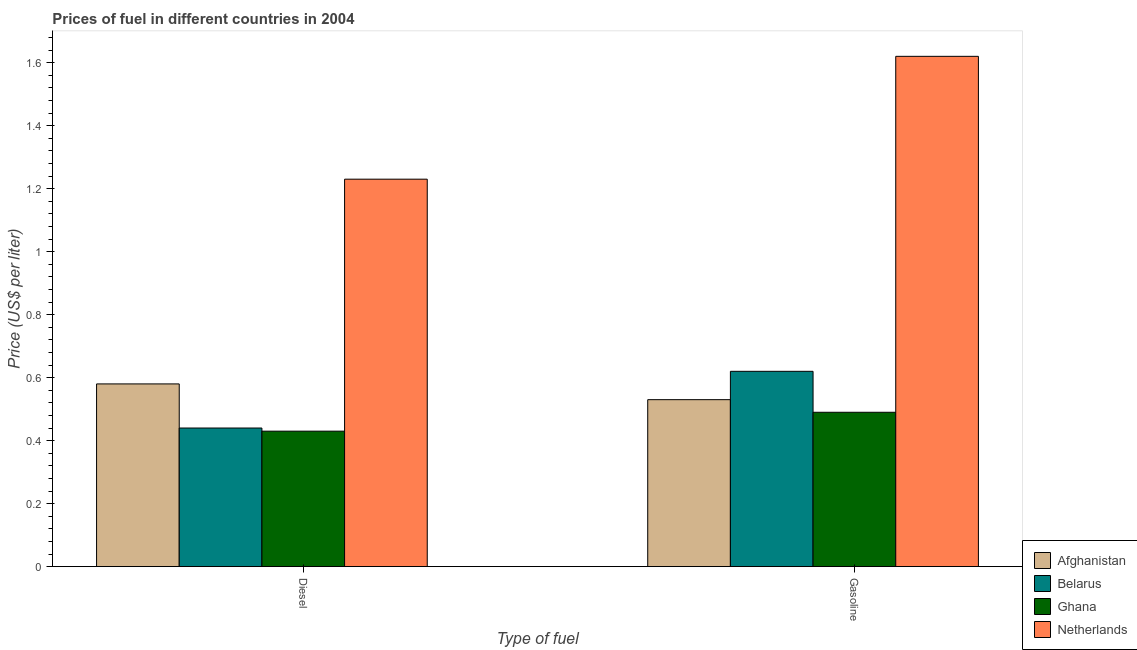How many groups of bars are there?
Your answer should be very brief. 2. Are the number of bars per tick equal to the number of legend labels?
Your response must be concise. Yes. What is the label of the 1st group of bars from the left?
Offer a terse response. Diesel. What is the diesel price in Belarus?
Offer a terse response. 0.44. Across all countries, what is the maximum gasoline price?
Offer a very short reply. 1.62. Across all countries, what is the minimum diesel price?
Offer a very short reply. 0.43. In which country was the diesel price maximum?
Ensure brevity in your answer.  Netherlands. What is the total gasoline price in the graph?
Your answer should be compact. 3.26. What is the difference between the diesel price in Netherlands and that in Belarus?
Ensure brevity in your answer.  0.79. What is the difference between the gasoline price in Ghana and the diesel price in Belarus?
Provide a short and direct response. 0.05. What is the average gasoline price per country?
Give a very brief answer. 0.81. What is the difference between the gasoline price and diesel price in Belarus?
Make the answer very short. 0.18. In how many countries, is the gasoline price greater than 1.4400000000000002 US$ per litre?
Your answer should be compact. 1. What is the ratio of the gasoline price in Afghanistan to that in Netherlands?
Give a very brief answer. 0.33. Is the diesel price in Netherlands less than that in Ghana?
Your response must be concise. No. In how many countries, is the diesel price greater than the average diesel price taken over all countries?
Your answer should be very brief. 1. What does the 1st bar from the left in Diesel represents?
Offer a very short reply. Afghanistan. What does the 3rd bar from the right in Gasoline represents?
Provide a short and direct response. Belarus. Does the graph contain any zero values?
Provide a succinct answer. No. Does the graph contain grids?
Your answer should be compact. No. Where does the legend appear in the graph?
Offer a very short reply. Bottom right. How many legend labels are there?
Give a very brief answer. 4. What is the title of the graph?
Ensure brevity in your answer.  Prices of fuel in different countries in 2004. Does "World" appear as one of the legend labels in the graph?
Provide a succinct answer. No. What is the label or title of the X-axis?
Your response must be concise. Type of fuel. What is the label or title of the Y-axis?
Provide a succinct answer. Price (US$ per liter). What is the Price (US$ per liter) of Afghanistan in Diesel?
Your answer should be compact. 0.58. What is the Price (US$ per liter) of Belarus in Diesel?
Keep it short and to the point. 0.44. What is the Price (US$ per liter) of Ghana in Diesel?
Ensure brevity in your answer.  0.43. What is the Price (US$ per liter) in Netherlands in Diesel?
Ensure brevity in your answer.  1.23. What is the Price (US$ per liter) in Afghanistan in Gasoline?
Provide a succinct answer. 0.53. What is the Price (US$ per liter) of Belarus in Gasoline?
Keep it short and to the point. 0.62. What is the Price (US$ per liter) of Ghana in Gasoline?
Keep it short and to the point. 0.49. What is the Price (US$ per liter) in Netherlands in Gasoline?
Provide a short and direct response. 1.62. Across all Type of fuel, what is the maximum Price (US$ per liter) of Afghanistan?
Your answer should be compact. 0.58. Across all Type of fuel, what is the maximum Price (US$ per liter) of Belarus?
Provide a short and direct response. 0.62. Across all Type of fuel, what is the maximum Price (US$ per liter) of Ghana?
Make the answer very short. 0.49. Across all Type of fuel, what is the maximum Price (US$ per liter) of Netherlands?
Keep it short and to the point. 1.62. Across all Type of fuel, what is the minimum Price (US$ per liter) in Afghanistan?
Offer a very short reply. 0.53. Across all Type of fuel, what is the minimum Price (US$ per liter) in Belarus?
Provide a short and direct response. 0.44. Across all Type of fuel, what is the minimum Price (US$ per liter) of Ghana?
Offer a very short reply. 0.43. Across all Type of fuel, what is the minimum Price (US$ per liter) of Netherlands?
Make the answer very short. 1.23. What is the total Price (US$ per liter) of Afghanistan in the graph?
Offer a terse response. 1.11. What is the total Price (US$ per liter) of Belarus in the graph?
Offer a very short reply. 1.06. What is the total Price (US$ per liter) in Netherlands in the graph?
Your answer should be compact. 2.85. What is the difference between the Price (US$ per liter) of Afghanistan in Diesel and that in Gasoline?
Make the answer very short. 0.05. What is the difference between the Price (US$ per liter) in Belarus in Diesel and that in Gasoline?
Keep it short and to the point. -0.18. What is the difference between the Price (US$ per liter) of Ghana in Diesel and that in Gasoline?
Keep it short and to the point. -0.06. What is the difference between the Price (US$ per liter) of Netherlands in Diesel and that in Gasoline?
Make the answer very short. -0.39. What is the difference between the Price (US$ per liter) in Afghanistan in Diesel and the Price (US$ per liter) in Belarus in Gasoline?
Provide a succinct answer. -0.04. What is the difference between the Price (US$ per liter) in Afghanistan in Diesel and the Price (US$ per liter) in Ghana in Gasoline?
Your answer should be very brief. 0.09. What is the difference between the Price (US$ per liter) in Afghanistan in Diesel and the Price (US$ per liter) in Netherlands in Gasoline?
Offer a terse response. -1.04. What is the difference between the Price (US$ per liter) of Belarus in Diesel and the Price (US$ per liter) of Netherlands in Gasoline?
Provide a short and direct response. -1.18. What is the difference between the Price (US$ per liter) in Ghana in Diesel and the Price (US$ per liter) in Netherlands in Gasoline?
Provide a short and direct response. -1.19. What is the average Price (US$ per liter) in Afghanistan per Type of fuel?
Your response must be concise. 0.56. What is the average Price (US$ per liter) of Belarus per Type of fuel?
Give a very brief answer. 0.53. What is the average Price (US$ per liter) in Ghana per Type of fuel?
Provide a short and direct response. 0.46. What is the average Price (US$ per liter) in Netherlands per Type of fuel?
Offer a terse response. 1.43. What is the difference between the Price (US$ per liter) in Afghanistan and Price (US$ per liter) in Belarus in Diesel?
Make the answer very short. 0.14. What is the difference between the Price (US$ per liter) of Afghanistan and Price (US$ per liter) of Netherlands in Diesel?
Make the answer very short. -0.65. What is the difference between the Price (US$ per liter) in Belarus and Price (US$ per liter) in Ghana in Diesel?
Your answer should be very brief. 0.01. What is the difference between the Price (US$ per liter) of Belarus and Price (US$ per liter) of Netherlands in Diesel?
Give a very brief answer. -0.79. What is the difference between the Price (US$ per liter) in Afghanistan and Price (US$ per liter) in Belarus in Gasoline?
Provide a succinct answer. -0.09. What is the difference between the Price (US$ per liter) of Afghanistan and Price (US$ per liter) of Ghana in Gasoline?
Your answer should be compact. 0.04. What is the difference between the Price (US$ per liter) in Afghanistan and Price (US$ per liter) in Netherlands in Gasoline?
Give a very brief answer. -1.09. What is the difference between the Price (US$ per liter) of Belarus and Price (US$ per liter) of Ghana in Gasoline?
Offer a terse response. 0.13. What is the difference between the Price (US$ per liter) in Ghana and Price (US$ per liter) in Netherlands in Gasoline?
Your answer should be very brief. -1.13. What is the ratio of the Price (US$ per liter) of Afghanistan in Diesel to that in Gasoline?
Your response must be concise. 1.09. What is the ratio of the Price (US$ per liter) of Belarus in Diesel to that in Gasoline?
Give a very brief answer. 0.71. What is the ratio of the Price (US$ per liter) in Ghana in Diesel to that in Gasoline?
Your answer should be compact. 0.88. What is the ratio of the Price (US$ per liter) of Netherlands in Diesel to that in Gasoline?
Your response must be concise. 0.76. What is the difference between the highest and the second highest Price (US$ per liter) in Afghanistan?
Offer a terse response. 0.05. What is the difference between the highest and the second highest Price (US$ per liter) in Belarus?
Provide a succinct answer. 0.18. What is the difference between the highest and the second highest Price (US$ per liter) in Netherlands?
Your answer should be compact. 0.39. What is the difference between the highest and the lowest Price (US$ per liter) of Afghanistan?
Ensure brevity in your answer.  0.05. What is the difference between the highest and the lowest Price (US$ per liter) of Belarus?
Offer a very short reply. 0.18. What is the difference between the highest and the lowest Price (US$ per liter) in Ghana?
Give a very brief answer. 0.06. What is the difference between the highest and the lowest Price (US$ per liter) of Netherlands?
Your answer should be very brief. 0.39. 